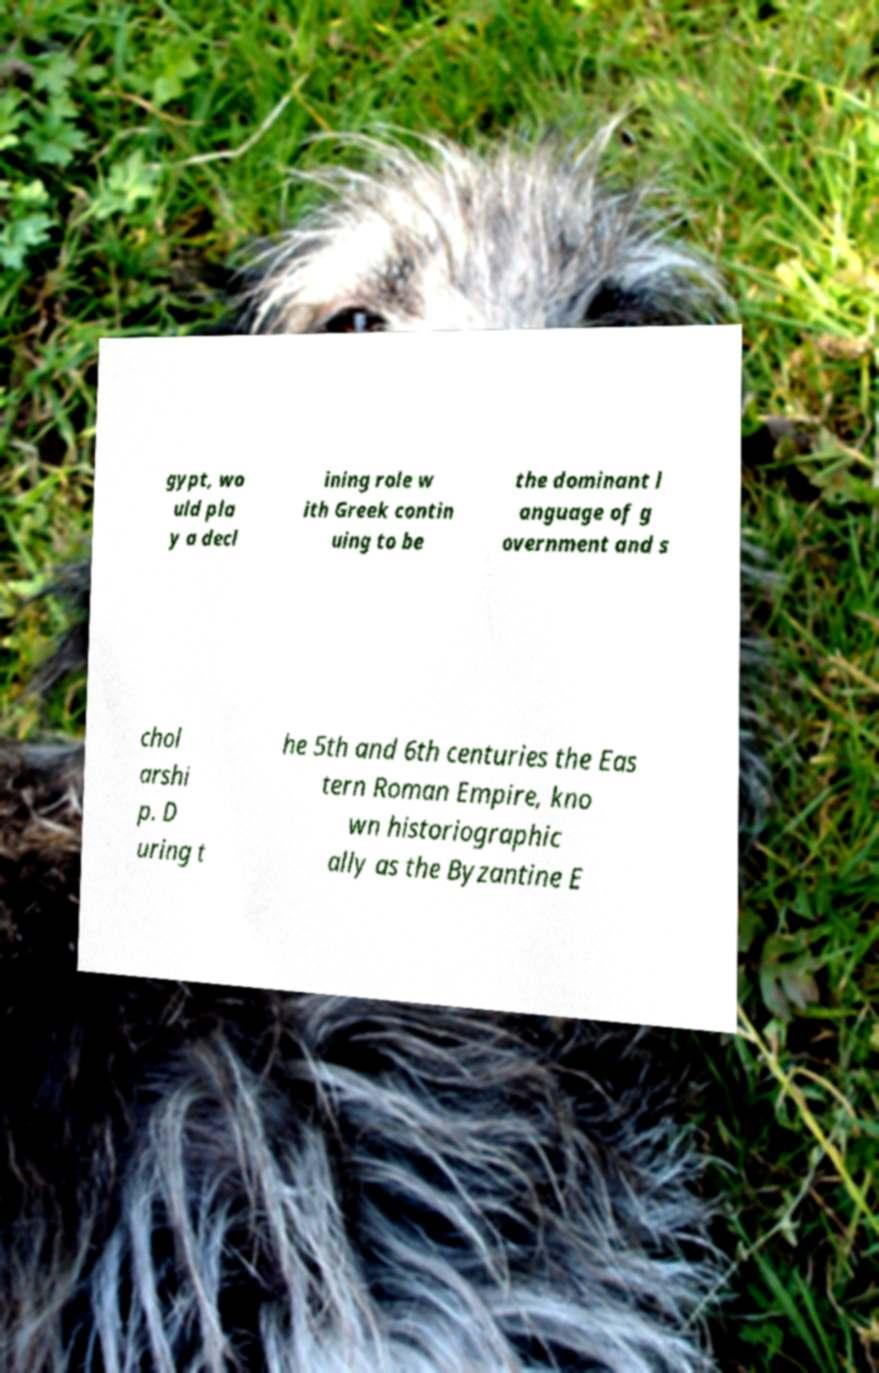For documentation purposes, I need the text within this image transcribed. Could you provide that? gypt, wo uld pla y a decl ining role w ith Greek contin uing to be the dominant l anguage of g overnment and s chol arshi p. D uring t he 5th and 6th centuries the Eas tern Roman Empire, kno wn historiographic ally as the Byzantine E 